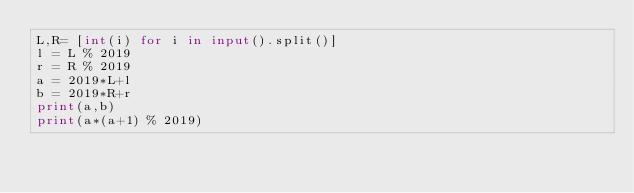<code> <loc_0><loc_0><loc_500><loc_500><_Python_>L,R= [int(i) for i in input().split()]
l = L % 2019
r = R % 2019
a = 2019*L+l
b = 2019*R+r
print(a,b)
print(a*(a+1) % 2019)</code> 